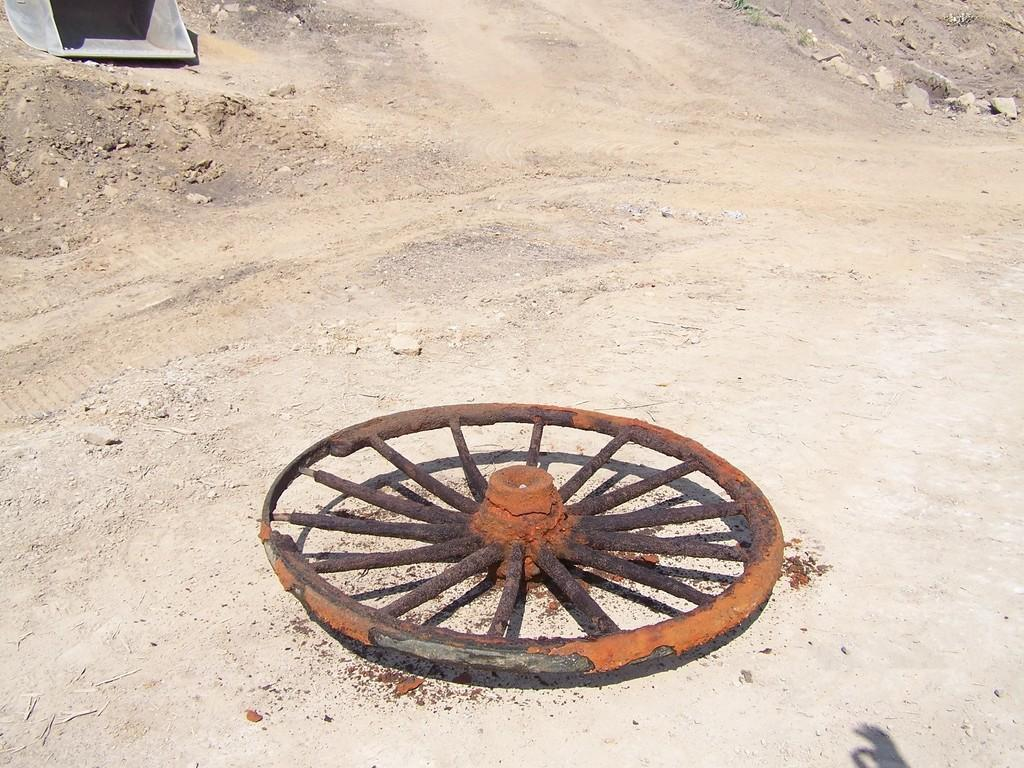Where was the picture taken? The picture was taken outside. What can be seen on the ground in the image? There is a wheel of a vehicle lying on the ground. What type of natural elements can be seen in the background? There are stones visible in the background. What type of man-made object can be seen in the background? There is a metal object in the background. How many boats are visible in the image? There are no boats present in the image. What type of copper object can be seen in the image? There is no copper object present in the image. 